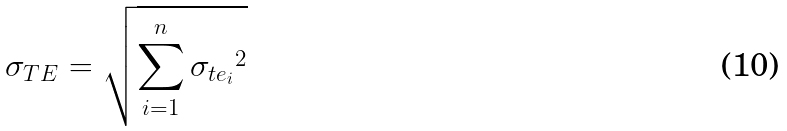<formula> <loc_0><loc_0><loc_500><loc_500>\sigma _ { T E } = \sqrt { \sum _ { i = 1 } ^ { n } { \sigma _ { t e _ { i } } } ^ { 2 } }</formula> 